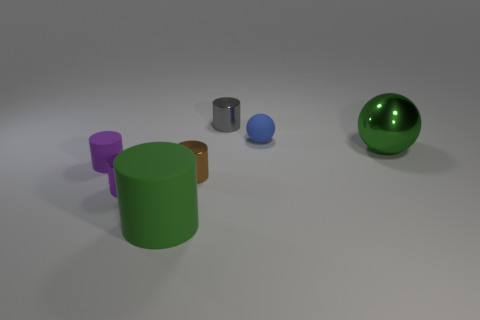Subtract all big matte cylinders. How many cylinders are left? 4 Subtract all gray cylinders. How many cylinders are left? 4 Subtract all blue cylinders. Subtract all purple blocks. How many cylinders are left? 5 Add 1 purple shiny cylinders. How many objects exist? 8 Subtract all balls. How many objects are left? 5 Subtract all small gray things. Subtract all large spheres. How many objects are left? 5 Add 5 small blue things. How many small blue things are left? 6 Add 1 gray cylinders. How many gray cylinders exist? 2 Subtract 0 purple cubes. How many objects are left? 7 